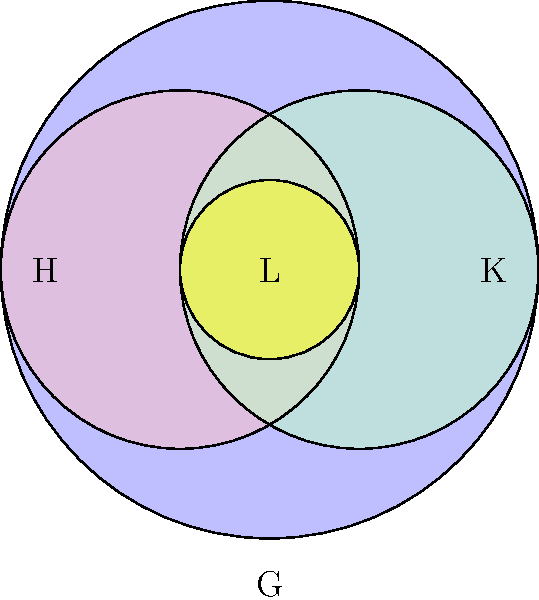In your quest to understand social media groups, you've come across this Venn diagram representing group theory. The largest circle G represents all your social media connections. H and K are subgroups of G, while L is a subgroup of both H and K. If you have 100 connections in G, 60 in H, 50 in K, and 30 in L, how many connections are exclusively in G (not in H or K)? Let's approach this step-by-step:

1) First, we need to understand what the question is asking. We're looking for connections that are in G but not in H or K.

2) We can use the principle of inclusion-exclusion to solve this:
   $$ |G| = |G \setminus (H \cup K)| + |H| + |K| - |H \cap K| $$

3) We know:
   $|G| = 100$ (total connections)
   $|H| = 60$
   $|K| = 50$
   $|L| = |H \cap K| = 30$ (L is the intersection of H and K)

4) Let's substitute these values:
   $$ 100 = |G \setminus (H \cup K)| + 60 + 50 - 30 $$

5) Simplify:
   $$ 100 = |G \setminus (H \cup K)| + 80 $$

6) Solve for $|G \setminus (H \cup K)|$:
   $$ |G \setminus (H \cup K)| = 100 - 80 = 20 $$

Therefore, there are 20 connections exclusively in G.
Answer: 20 